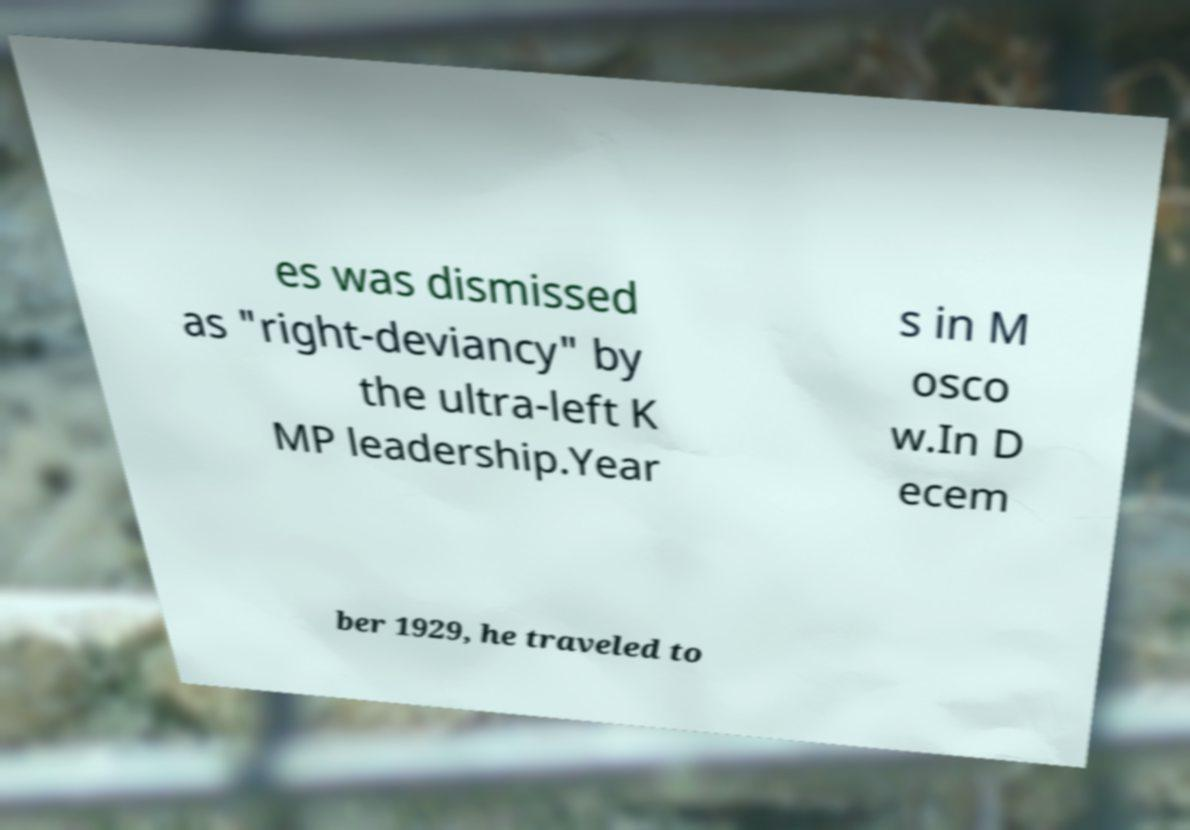For documentation purposes, I need the text within this image transcribed. Could you provide that? es was dismissed as "right-deviancy" by the ultra-left K MP leadership.Year s in M osco w.In D ecem ber 1929, he traveled to 